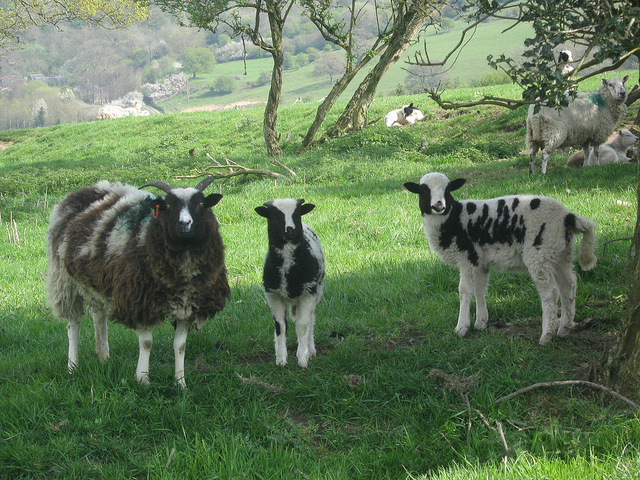<image>Which animal has the most unusual pattern? It is ambiguous which animal has the most unusual pattern. Which animal has the most unusual pattern? I am not sure which animal has the most unusual pattern. It can be seen 'goat', 'ram' or 'sheep'. 